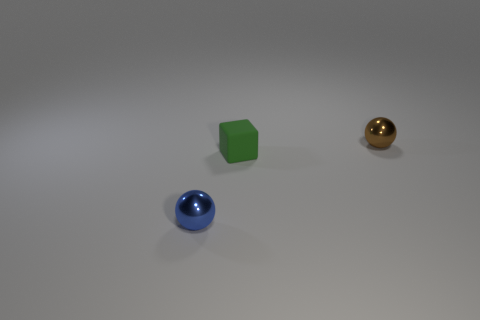How would you describe the lighting and shadows in the image? The lighting in the image is soft and diffuse, coming from the upper left. It casts gentle shadows on the right side of the objects, indicating the light source is not directly overhead but angled. 